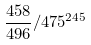<formula> <loc_0><loc_0><loc_500><loc_500>\frac { 4 5 8 } { 4 9 6 } / 4 7 5 ^ { 2 4 5 }</formula> 